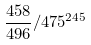<formula> <loc_0><loc_0><loc_500><loc_500>\frac { 4 5 8 } { 4 9 6 } / 4 7 5 ^ { 2 4 5 }</formula> 